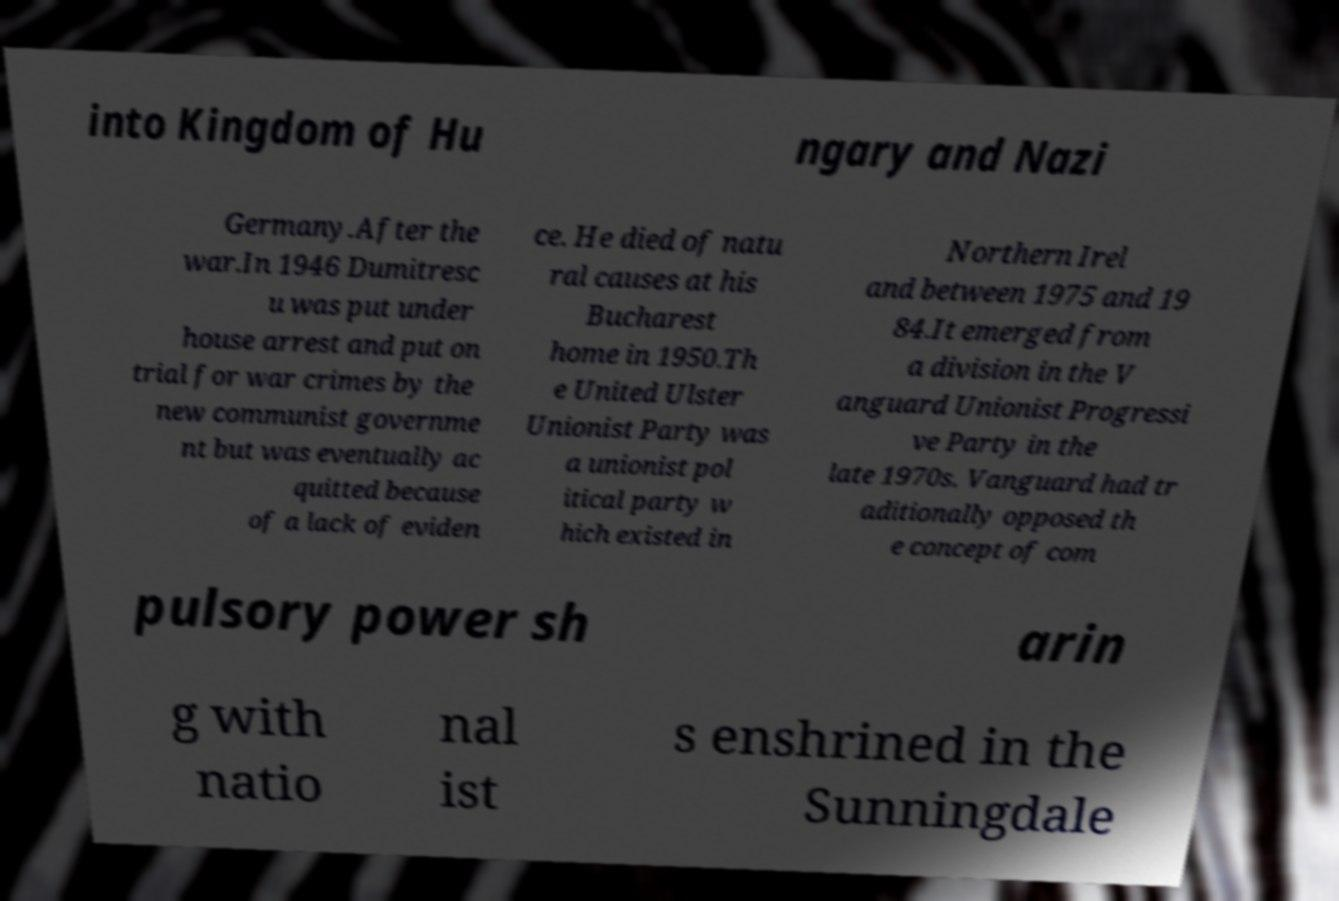Can you accurately transcribe the text from the provided image for me? into Kingdom of Hu ngary and Nazi Germany.After the war.In 1946 Dumitresc u was put under house arrest and put on trial for war crimes by the new communist governme nt but was eventually ac quitted because of a lack of eviden ce. He died of natu ral causes at his Bucharest home in 1950.Th e United Ulster Unionist Party was a unionist pol itical party w hich existed in Northern Irel and between 1975 and 19 84.It emerged from a division in the V anguard Unionist Progressi ve Party in the late 1970s. Vanguard had tr aditionally opposed th e concept of com pulsory power sh arin g with natio nal ist s enshrined in the Sunningdale 